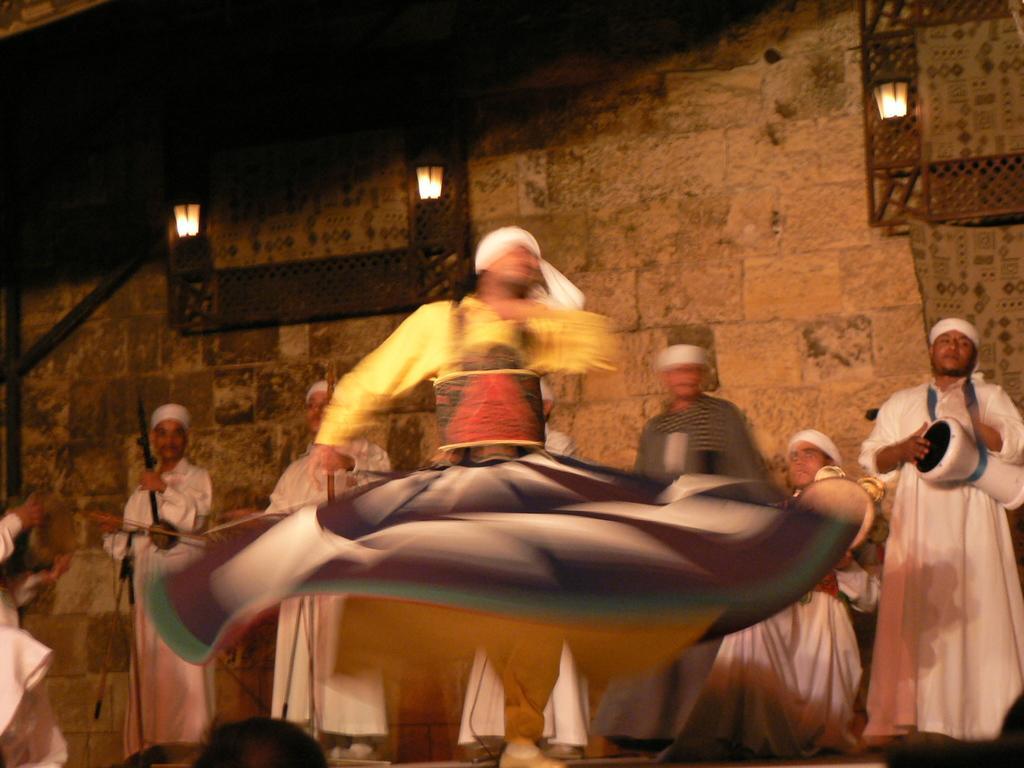Could you give a brief overview of what you see in this image? There is a person dancing. In the back some people are holding musical instruments and playing. In the background there is a wall. 